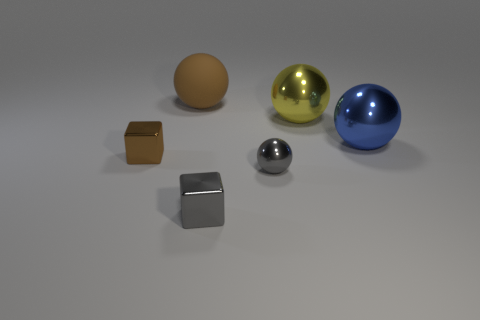How do the colors of the objects compare to one another? Within the image, there is a rich variety of colors. The largest sphere is a vibrant blue, rendering it quite eye-catching. The golden sphere offers a stark contrast with a warm and reflective hue. The small cubic and spherical objects are more subdued in coloring, with the cube displaying a matte brown and the smallest sphere showcasing a sleek silver. The remaining sphere stands out less with its neutral gray color, and the background provides a soft, muted setting for these objects. 